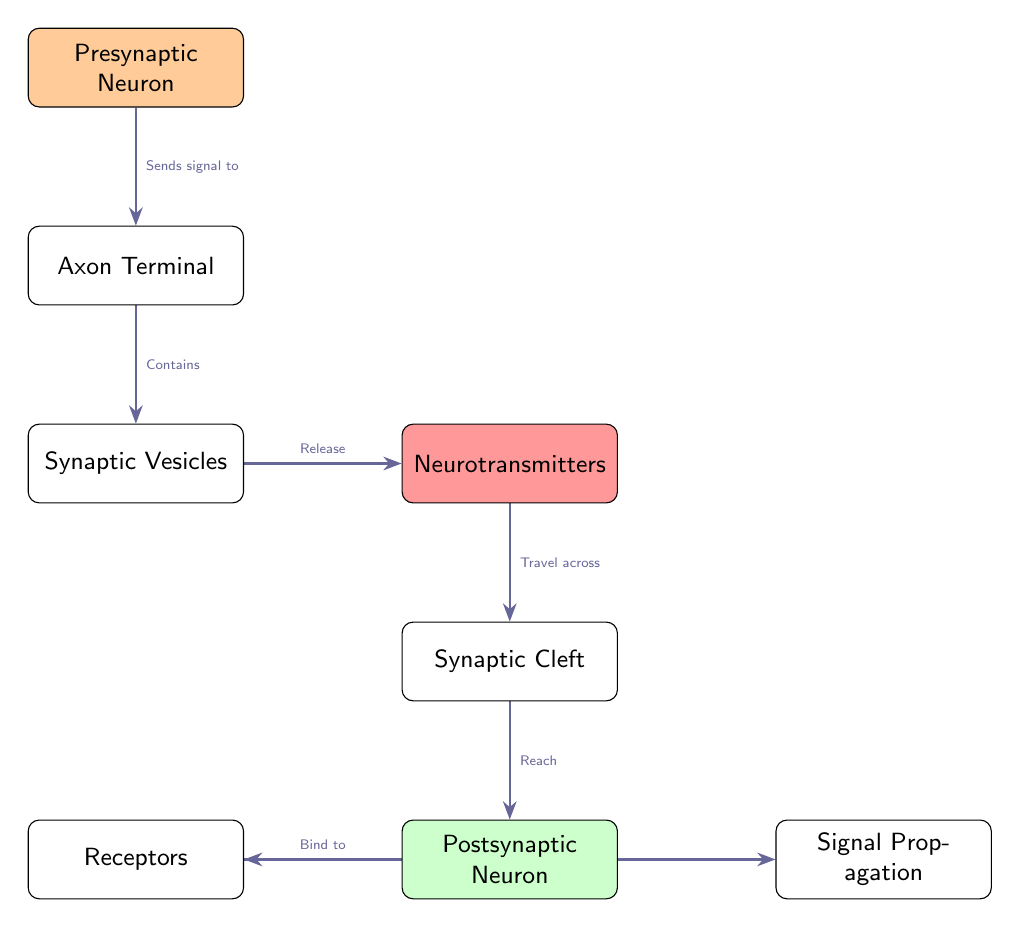What is the first node in the diagram? The first node is labeled "Presynaptic Neuron," which can be found at the top of the diagram.
Answer: Presynaptic Neuron What is found in the axon terminal? The axon terminal contains "Synaptic Vesicles," which is indicated directly below the axon terminal in the diagram.
Answer: Synaptic Vesicles How do neurotransmitters travel across to the postsynaptic neuron? Neurotransmitters "Travel across" the "Synaptic Cleft," as indicated by the edge connecting these two nodes in the diagram.
Answer: Travel across What binds to the receptors? The node identified as "Neurotransmitters" binds to the "Receptors," which is shown in the flow of the diagram from the neurotransmitter node to the receptor node.
Answer: Neurotransmitters What is the final action triggered after receptors bind? The final action triggered is "Signal Propagation," which occurs as the last step in the sequence from receptors.
Answer: Signal Propagation How many edges are used to represent the neurotransmitter's journey from vesicles to signal propagation? There are five edges representing the neurotransmitter's journey from vesicles to signal propagation, showing each step of the process in the diagram.
Answer: 5 What color is used for the presynaptic neuron? The "Presynaptic Neuron" is filled with a color defined as "presynapticcolor," which is a light orange hue.
Answer: Light orange Which node is directly above the synaptic cleft? The node directly above the synaptic cleft is "Neurotransmitters," which is positioned just above it according to the layout of the diagram.
Answer: Neurotransmitters What is the relationship between receptors and signal propagation? The relationship is that the "Receptors" bind to neurotransmitters and "Triggers" signal propagation, indicated by the edge connecting these two nodes.
Answer: Triggers 